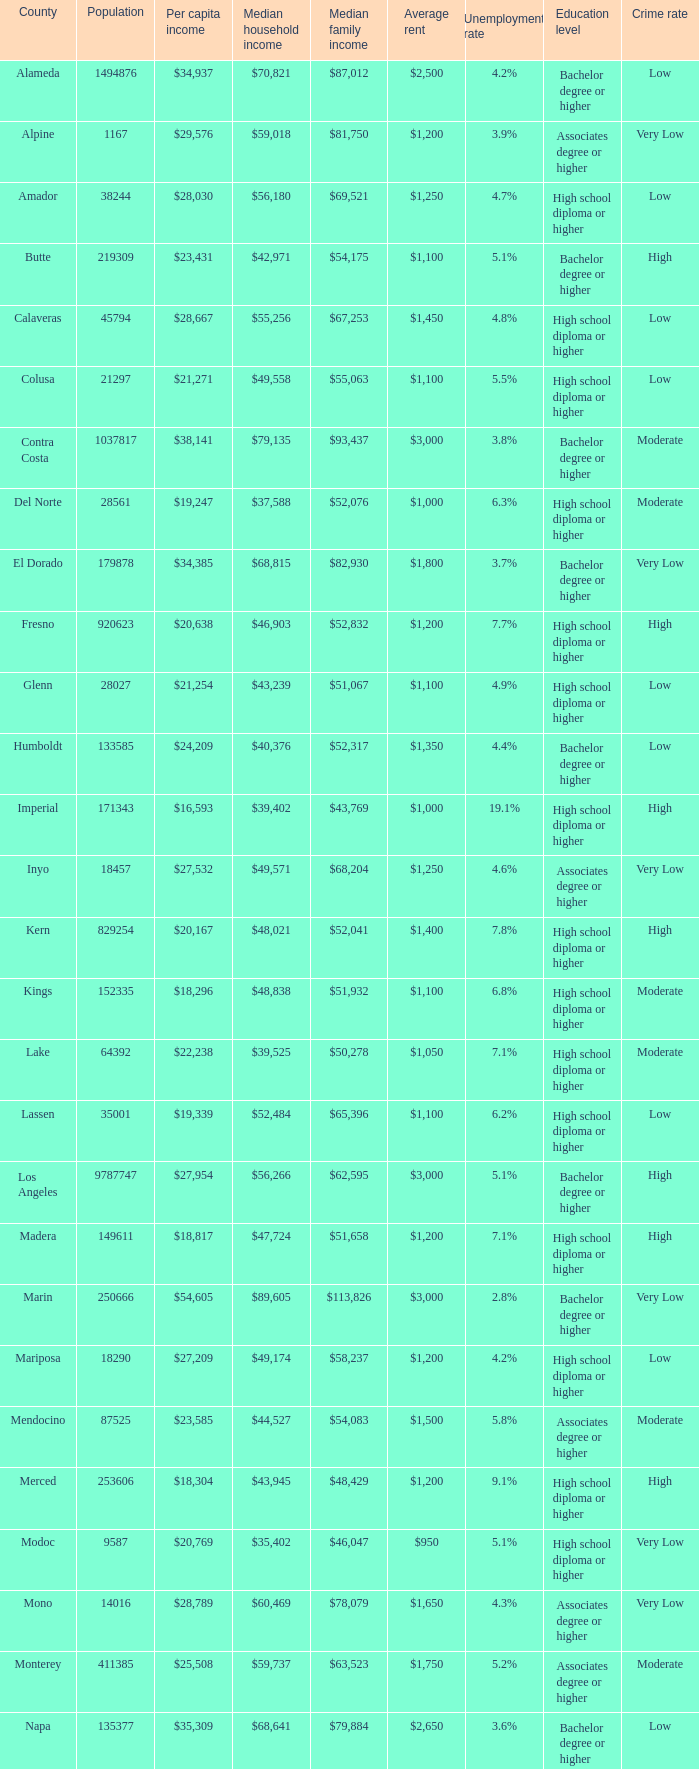What is the average household income in sacramento? $56,553. 